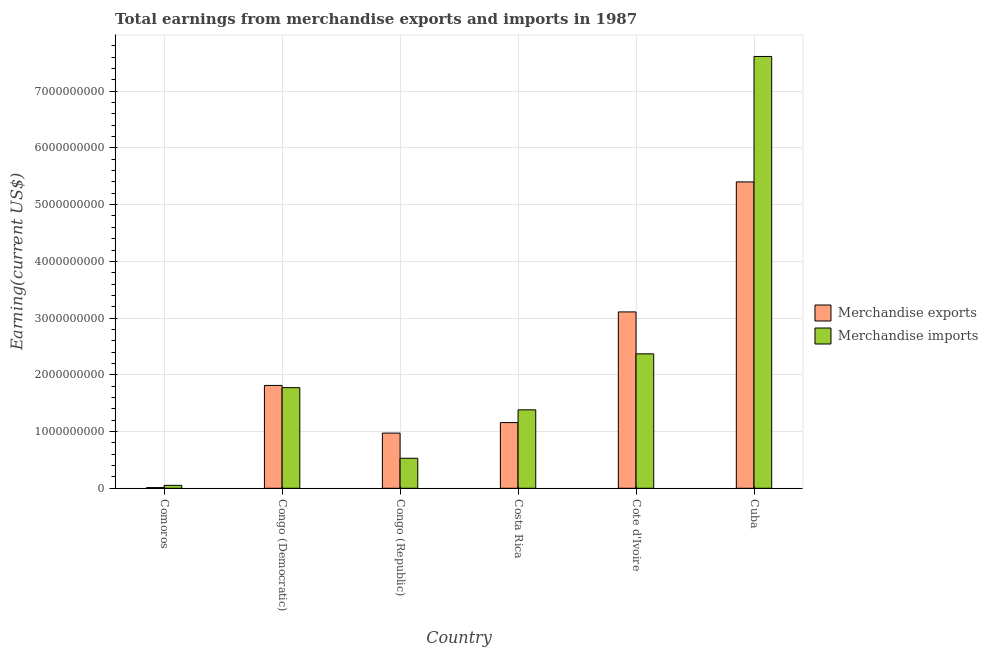How many groups of bars are there?
Keep it short and to the point. 6. Are the number of bars per tick equal to the number of legend labels?
Provide a succinct answer. Yes. Are the number of bars on each tick of the X-axis equal?
Ensure brevity in your answer.  Yes. What is the label of the 6th group of bars from the left?
Offer a terse response. Cuba. What is the earnings from merchandise imports in Comoros?
Offer a very short reply. 5.20e+07. Across all countries, what is the maximum earnings from merchandise exports?
Ensure brevity in your answer.  5.40e+09. Across all countries, what is the minimum earnings from merchandise exports?
Offer a terse response. 1.20e+07. In which country was the earnings from merchandise imports maximum?
Make the answer very short. Cuba. In which country was the earnings from merchandise imports minimum?
Your response must be concise. Comoros. What is the total earnings from merchandise imports in the graph?
Give a very brief answer. 1.37e+1. What is the difference between the earnings from merchandise exports in Comoros and that in Congo (Republic)?
Offer a very short reply. -9.61e+08. What is the difference between the earnings from merchandise imports in Congo (Republic) and the earnings from merchandise exports in Cote d'Ivoire?
Ensure brevity in your answer.  -2.58e+09. What is the average earnings from merchandise exports per country?
Give a very brief answer. 2.08e+09. What is the difference between the earnings from merchandise imports and earnings from merchandise exports in Congo (Republic)?
Your answer should be compact. -4.44e+08. In how many countries, is the earnings from merchandise imports greater than 5000000000 US$?
Keep it short and to the point. 1. What is the ratio of the earnings from merchandise imports in Congo (Democratic) to that in Costa Rica?
Give a very brief answer. 1.28. What is the difference between the highest and the second highest earnings from merchandise imports?
Provide a succinct answer. 5.24e+09. What is the difference between the highest and the lowest earnings from merchandise exports?
Give a very brief answer. 5.39e+09. In how many countries, is the earnings from merchandise imports greater than the average earnings from merchandise imports taken over all countries?
Make the answer very short. 2. Is the sum of the earnings from merchandise imports in Congo (Democratic) and Costa Rica greater than the maximum earnings from merchandise exports across all countries?
Provide a succinct answer. No. What does the 2nd bar from the left in Cuba represents?
Your answer should be very brief. Merchandise imports. How many bars are there?
Provide a succinct answer. 12. How many countries are there in the graph?
Provide a succinct answer. 6. What is the difference between two consecutive major ticks on the Y-axis?
Ensure brevity in your answer.  1.00e+09. Are the values on the major ticks of Y-axis written in scientific E-notation?
Keep it short and to the point. No. Does the graph contain any zero values?
Make the answer very short. No. Where does the legend appear in the graph?
Provide a short and direct response. Center right. What is the title of the graph?
Keep it short and to the point. Total earnings from merchandise exports and imports in 1987. Does "Manufacturing industries and construction" appear as one of the legend labels in the graph?
Give a very brief answer. No. What is the label or title of the Y-axis?
Provide a succinct answer. Earning(current US$). What is the Earning(current US$) in Merchandise imports in Comoros?
Your response must be concise. 5.20e+07. What is the Earning(current US$) in Merchandise exports in Congo (Democratic)?
Your response must be concise. 1.81e+09. What is the Earning(current US$) of Merchandise imports in Congo (Democratic)?
Offer a very short reply. 1.77e+09. What is the Earning(current US$) of Merchandise exports in Congo (Republic)?
Ensure brevity in your answer.  9.73e+08. What is the Earning(current US$) in Merchandise imports in Congo (Republic)?
Make the answer very short. 5.29e+08. What is the Earning(current US$) in Merchandise exports in Costa Rica?
Provide a succinct answer. 1.16e+09. What is the Earning(current US$) in Merchandise imports in Costa Rica?
Your response must be concise. 1.38e+09. What is the Earning(current US$) of Merchandise exports in Cote d'Ivoire?
Your answer should be compact. 3.11e+09. What is the Earning(current US$) in Merchandise imports in Cote d'Ivoire?
Keep it short and to the point. 2.37e+09. What is the Earning(current US$) of Merchandise exports in Cuba?
Offer a very short reply. 5.40e+09. What is the Earning(current US$) of Merchandise imports in Cuba?
Provide a succinct answer. 7.61e+09. Across all countries, what is the maximum Earning(current US$) in Merchandise exports?
Ensure brevity in your answer.  5.40e+09. Across all countries, what is the maximum Earning(current US$) of Merchandise imports?
Give a very brief answer. 7.61e+09. Across all countries, what is the minimum Earning(current US$) of Merchandise exports?
Your answer should be compact. 1.20e+07. Across all countries, what is the minimum Earning(current US$) in Merchandise imports?
Your response must be concise. 5.20e+07. What is the total Earning(current US$) of Merchandise exports in the graph?
Your answer should be compact. 1.25e+1. What is the total Earning(current US$) in Merchandise imports in the graph?
Keep it short and to the point. 1.37e+1. What is the difference between the Earning(current US$) of Merchandise exports in Comoros and that in Congo (Democratic)?
Provide a succinct answer. -1.80e+09. What is the difference between the Earning(current US$) of Merchandise imports in Comoros and that in Congo (Democratic)?
Your answer should be compact. -1.72e+09. What is the difference between the Earning(current US$) in Merchandise exports in Comoros and that in Congo (Republic)?
Ensure brevity in your answer.  -9.61e+08. What is the difference between the Earning(current US$) in Merchandise imports in Comoros and that in Congo (Republic)?
Keep it short and to the point. -4.77e+08. What is the difference between the Earning(current US$) in Merchandise exports in Comoros and that in Costa Rica?
Offer a terse response. -1.15e+09. What is the difference between the Earning(current US$) of Merchandise imports in Comoros and that in Costa Rica?
Your answer should be very brief. -1.33e+09. What is the difference between the Earning(current US$) in Merchandise exports in Comoros and that in Cote d'Ivoire?
Provide a succinct answer. -3.10e+09. What is the difference between the Earning(current US$) of Merchandise imports in Comoros and that in Cote d'Ivoire?
Offer a terse response. -2.32e+09. What is the difference between the Earning(current US$) of Merchandise exports in Comoros and that in Cuba?
Offer a terse response. -5.39e+09. What is the difference between the Earning(current US$) in Merchandise imports in Comoros and that in Cuba?
Ensure brevity in your answer.  -7.56e+09. What is the difference between the Earning(current US$) in Merchandise exports in Congo (Democratic) and that in Congo (Republic)?
Give a very brief answer. 8.40e+08. What is the difference between the Earning(current US$) of Merchandise imports in Congo (Democratic) and that in Congo (Republic)?
Provide a succinct answer. 1.24e+09. What is the difference between the Earning(current US$) in Merchandise exports in Congo (Democratic) and that in Costa Rica?
Provide a succinct answer. 6.55e+08. What is the difference between the Earning(current US$) in Merchandise imports in Congo (Democratic) and that in Costa Rica?
Your answer should be very brief. 3.91e+08. What is the difference between the Earning(current US$) in Merchandise exports in Congo (Democratic) and that in Cote d'Ivoire?
Give a very brief answer. -1.30e+09. What is the difference between the Earning(current US$) of Merchandise imports in Congo (Democratic) and that in Cote d'Ivoire?
Provide a succinct answer. -5.96e+08. What is the difference between the Earning(current US$) of Merchandise exports in Congo (Democratic) and that in Cuba?
Make the answer very short. -3.59e+09. What is the difference between the Earning(current US$) of Merchandise imports in Congo (Democratic) and that in Cuba?
Keep it short and to the point. -5.84e+09. What is the difference between the Earning(current US$) in Merchandise exports in Congo (Republic) and that in Costa Rica?
Ensure brevity in your answer.  -1.85e+08. What is the difference between the Earning(current US$) in Merchandise imports in Congo (Republic) and that in Costa Rica?
Offer a very short reply. -8.54e+08. What is the difference between the Earning(current US$) of Merchandise exports in Congo (Republic) and that in Cote d'Ivoire?
Your answer should be compact. -2.14e+09. What is the difference between the Earning(current US$) of Merchandise imports in Congo (Republic) and that in Cote d'Ivoire?
Your answer should be very brief. -1.84e+09. What is the difference between the Earning(current US$) of Merchandise exports in Congo (Republic) and that in Cuba?
Make the answer very short. -4.43e+09. What is the difference between the Earning(current US$) of Merchandise imports in Congo (Republic) and that in Cuba?
Your answer should be compact. -7.08e+09. What is the difference between the Earning(current US$) of Merchandise exports in Costa Rica and that in Cote d'Ivoire?
Provide a succinct answer. -1.95e+09. What is the difference between the Earning(current US$) in Merchandise imports in Costa Rica and that in Cote d'Ivoire?
Give a very brief answer. -9.87e+08. What is the difference between the Earning(current US$) of Merchandise exports in Costa Rica and that in Cuba?
Keep it short and to the point. -4.24e+09. What is the difference between the Earning(current US$) of Merchandise imports in Costa Rica and that in Cuba?
Make the answer very short. -6.23e+09. What is the difference between the Earning(current US$) of Merchandise exports in Cote d'Ivoire and that in Cuba?
Offer a very short reply. -2.29e+09. What is the difference between the Earning(current US$) in Merchandise imports in Cote d'Ivoire and that in Cuba?
Keep it short and to the point. -5.24e+09. What is the difference between the Earning(current US$) in Merchandise exports in Comoros and the Earning(current US$) in Merchandise imports in Congo (Democratic)?
Your answer should be compact. -1.76e+09. What is the difference between the Earning(current US$) of Merchandise exports in Comoros and the Earning(current US$) of Merchandise imports in Congo (Republic)?
Ensure brevity in your answer.  -5.17e+08. What is the difference between the Earning(current US$) in Merchandise exports in Comoros and the Earning(current US$) in Merchandise imports in Costa Rica?
Ensure brevity in your answer.  -1.37e+09. What is the difference between the Earning(current US$) of Merchandise exports in Comoros and the Earning(current US$) of Merchandise imports in Cote d'Ivoire?
Your answer should be compact. -2.36e+09. What is the difference between the Earning(current US$) in Merchandise exports in Comoros and the Earning(current US$) in Merchandise imports in Cuba?
Ensure brevity in your answer.  -7.60e+09. What is the difference between the Earning(current US$) of Merchandise exports in Congo (Democratic) and the Earning(current US$) of Merchandise imports in Congo (Republic)?
Your answer should be very brief. 1.28e+09. What is the difference between the Earning(current US$) in Merchandise exports in Congo (Democratic) and the Earning(current US$) in Merchandise imports in Costa Rica?
Ensure brevity in your answer.  4.30e+08. What is the difference between the Earning(current US$) of Merchandise exports in Congo (Democratic) and the Earning(current US$) of Merchandise imports in Cote d'Ivoire?
Keep it short and to the point. -5.57e+08. What is the difference between the Earning(current US$) of Merchandise exports in Congo (Democratic) and the Earning(current US$) of Merchandise imports in Cuba?
Your response must be concise. -5.80e+09. What is the difference between the Earning(current US$) of Merchandise exports in Congo (Republic) and the Earning(current US$) of Merchandise imports in Costa Rica?
Offer a very short reply. -4.10e+08. What is the difference between the Earning(current US$) in Merchandise exports in Congo (Republic) and the Earning(current US$) in Merchandise imports in Cote d'Ivoire?
Provide a succinct answer. -1.40e+09. What is the difference between the Earning(current US$) in Merchandise exports in Congo (Republic) and the Earning(current US$) in Merchandise imports in Cuba?
Your answer should be compact. -6.64e+09. What is the difference between the Earning(current US$) in Merchandise exports in Costa Rica and the Earning(current US$) in Merchandise imports in Cote d'Ivoire?
Make the answer very short. -1.21e+09. What is the difference between the Earning(current US$) in Merchandise exports in Costa Rica and the Earning(current US$) in Merchandise imports in Cuba?
Your answer should be very brief. -6.45e+09. What is the difference between the Earning(current US$) of Merchandise exports in Cote d'Ivoire and the Earning(current US$) of Merchandise imports in Cuba?
Your answer should be very brief. -4.50e+09. What is the average Earning(current US$) in Merchandise exports per country?
Keep it short and to the point. 2.08e+09. What is the average Earning(current US$) of Merchandise imports per country?
Provide a short and direct response. 2.29e+09. What is the difference between the Earning(current US$) of Merchandise exports and Earning(current US$) of Merchandise imports in Comoros?
Your answer should be compact. -4.00e+07. What is the difference between the Earning(current US$) in Merchandise exports and Earning(current US$) in Merchandise imports in Congo (Democratic)?
Offer a terse response. 3.90e+07. What is the difference between the Earning(current US$) in Merchandise exports and Earning(current US$) in Merchandise imports in Congo (Republic)?
Keep it short and to the point. 4.44e+08. What is the difference between the Earning(current US$) in Merchandise exports and Earning(current US$) in Merchandise imports in Costa Rica?
Offer a terse response. -2.25e+08. What is the difference between the Earning(current US$) of Merchandise exports and Earning(current US$) of Merchandise imports in Cote d'Ivoire?
Offer a very short reply. 7.39e+08. What is the difference between the Earning(current US$) of Merchandise exports and Earning(current US$) of Merchandise imports in Cuba?
Your answer should be compact. -2.21e+09. What is the ratio of the Earning(current US$) of Merchandise exports in Comoros to that in Congo (Democratic)?
Provide a succinct answer. 0.01. What is the ratio of the Earning(current US$) in Merchandise imports in Comoros to that in Congo (Democratic)?
Your answer should be compact. 0.03. What is the ratio of the Earning(current US$) of Merchandise exports in Comoros to that in Congo (Republic)?
Give a very brief answer. 0.01. What is the ratio of the Earning(current US$) in Merchandise imports in Comoros to that in Congo (Republic)?
Your response must be concise. 0.1. What is the ratio of the Earning(current US$) of Merchandise exports in Comoros to that in Costa Rica?
Provide a succinct answer. 0.01. What is the ratio of the Earning(current US$) in Merchandise imports in Comoros to that in Costa Rica?
Give a very brief answer. 0.04. What is the ratio of the Earning(current US$) in Merchandise exports in Comoros to that in Cote d'Ivoire?
Make the answer very short. 0. What is the ratio of the Earning(current US$) in Merchandise imports in Comoros to that in Cote d'Ivoire?
Give a very brief answer. 0.02. What is the ratio of the Earning(current US$) of Merchandise exports in Comoros to that in Cuba?
Ensure brevity in your answer.  0. What is the ratio of the Earning(current US$) of Merchandise imports in Comoros to that in Cuba?
Your answer should be very brief. 0.01. What is the ratio of the Earning(current US$) in Merchandise exports in Congo (Democratic) to that in Congo (Republic)?
Ensure brevity in your answer.  1.86. What is the ratio of the Earning(current US$) of Merchandise imports in Congo (Democratic) to that in Congo (Republic)?
Your answer should be compact. 3.35. What is the ratio of the Earning(current US$) in Merchandise exports in Congo (Democratic) to that in Costa Rica?
Offer a terse response. 1.57. What is the ratio of the Earning(current US$) in Merchandise imports in Congo (Democratic) to that in Costa Rica?
Give a very brief answer. 1.28. What is the ratio of the Earning(current US$) in Merchandise exports in Congo (Democratic) to that in Cote d'Ivoire?
Keep it short and to the point. 0.58. What is the ratio of the Earning(current US$) in Merchandise imports in Congo (Democratic) to that in Cote d'Ivoire?
Provide a short and direct response. 0.75. What is the ratio of the Earning(current US$) in Merchandise exports in Congo (Democratic) to that in Cuba?
Your answer should be very brief. 0.34. What is the ratio of the Earning(current US$) of Merchandise imports in Congo (Democratic) to that in Cuba?
Your answer should be compact. 0.23. What is the ratio of the Earning(current US$) in Merchandise exports in Congo (Republic) to that in Costa Rica?
Your response must be concise. 0.84. What is the ratio of the Earning(current US$) in Merchandise imports in Congo (Republic) to that in Costa Rica?
Ensure brevity in your answer.  0.38. What is the ratio of the Earning(current US$) of Merchandise exports in Congo (Republic) to that in Cote d'Ivoire?
Offer a very short reply. 0.31. What is the ratio of the Earning(current US$) of Merchandise imports in Congo (Republic) to that in Cote d'Ivoire?
Offer a very short reply. 0.22. What is the ratio of the Earning(current US$) in Merchandise exports in Congo (Republic) to that in Cuba?
Your answer should be compact. 0.18. What is the ratio of the Earning(current US$) of Merchandise imports in Congo (Republic) to that in Cuba?
Your answer should be compact. 0.07. What is the ratio of the Earning(current US$) in Merchandise exports in Costa Rica to that in Cote d'Ivoire?
Ensure brevity in your answer.  0.37. What is the ratio of the Earning(current US$) in Merchandise imports in Costa Rica to that in Cote d'Ivoire?
Give a very brief answer. 0.58. What is the ratio of the Earning(current US$) of Merchandise exports in Costa Rica to that in Cuba?
Your answer should be compact. 0.21. What is the ratio of the Earning(current US$) of Merchandise imports in Costa Rica to that in Cuba?
Keep it short and to the point. 0.18. What is the ratio of the Earning(current US$) of Merchandise exports in Cote d'Ivoire to that in Cuba?
Provide a succinct answer. 0.58. What is the ratio of the Earning(current US$) of Merchandise imports in Cote d'Ivoire to that in Cuba?
Offer a terse response. 0.31. What is the difference between the highest and the second highest Earning(current US$) in Merchandise exports?
Your answer should be very brief. 2.29e+09. What is the difference between the highest and the second highest Earning(current US$) in Merchandise imports?
Give a very brief answer. 5.24e+09. What is the difference between the highest and the lowest Earning(current US$) of Merchandise exports?
Provide a short and direct response. 5.39e+09. What is the difference between the highest and the lowest Earning(current US$) of Merchandise imports?
Ensure brevity in your answer.  7.56e+09. 